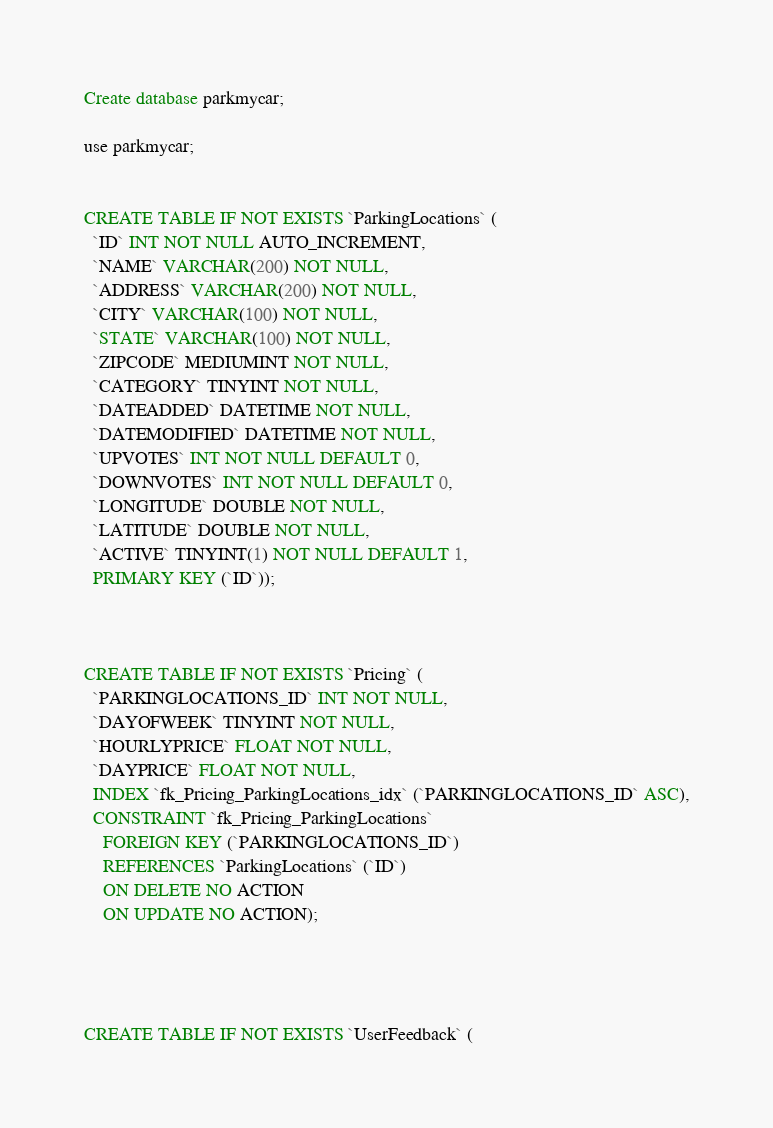<code> <loc_0><loc_0><loc_500><loc_500><_SQL_>Create database parkmycar;

use parkmycar;


CREATE TABLE IF NOT EXISTS `ParkingLocations` (
  `ID` INT NOT NULL AUTO_INCREMENT,
  `NAME` VARCHAR(200) NOT NULL,
  `ADDRESS` VARCHAR(200) NOT NULL,
  `CITY` VARCHAR(100) NOT NULL,
  `STATE` VARCHAR(100) NOT NULL,
  `ZIPCODE` MEDIUMINT NOT NULL,
  `CATEGORY` TINYINT NOT NULL,
  `DATEADDED` DATETIME NOT NULL,
  `DATEMODIFIED` DATETIME NOT NULL,
  `UPVOTES` INT NOT NULL DEFAULT 0,
  `DOWNVOTES` INT NOT NULL DEFAULT 0,
  `LONGITUDE` DOUBLE NOT NULL,
  `LATITUDE` DOUBLE NOT NULL,
  `ACTIVE` TINYINT(1) NOT NULL DEFAULT 1,
  PRIMARY KEY (`ID`));



CREATE TABLE IF NOT EXISTS `Pricing` (
  `PARKINGLOCATIONS_ID` INT NOT NULL,
  `DAYOFWEEK` TINYINT NOT NULL,
  `HOURLYPRICE` FLOAT NOT NULL,
  `DAYPRICE` FLOAT NOT NULL,
  INDEX `fk_Pricing_ParkingLocations_idx` (`PARKINGLOCATIONS_ID` ASC),
  CONSTRAINT `fk_Pricing_ParkingLocations`
    FOREIGN KEY (`PARKINGLOCATIONS_ID`)
    REFERENCES `ParkingLocations` (`ID`)
    ON DELETE NO ACTION
    ON UPDATE NO ACTION);




CREATE TABLE IF NOT EXISTS `UserFeedback` (</code> 